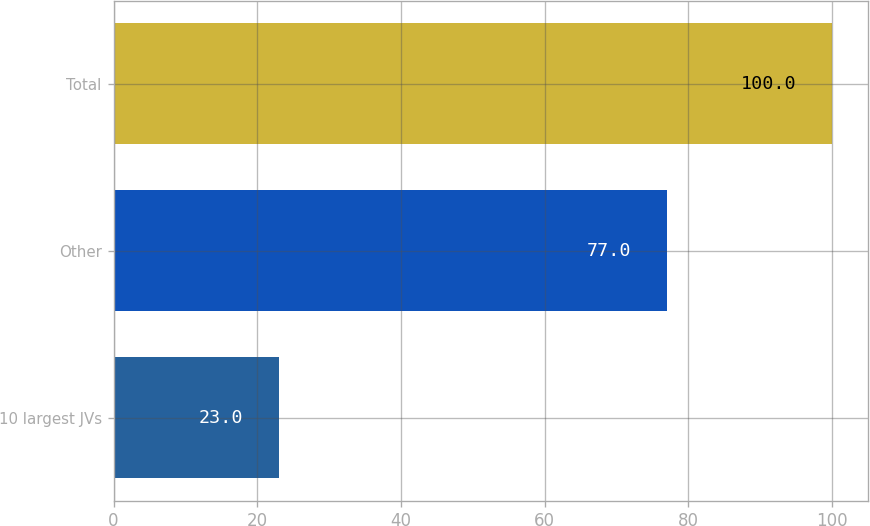Convert chart to OTSL. <chart><loc_0><loc_0><loc_500><loc_500><bar_chart><fcel>10 largest JVs<fcel>Other<fcel>Total<nl><fcel>23<fcel>77<fcel>100<nl></chart> 